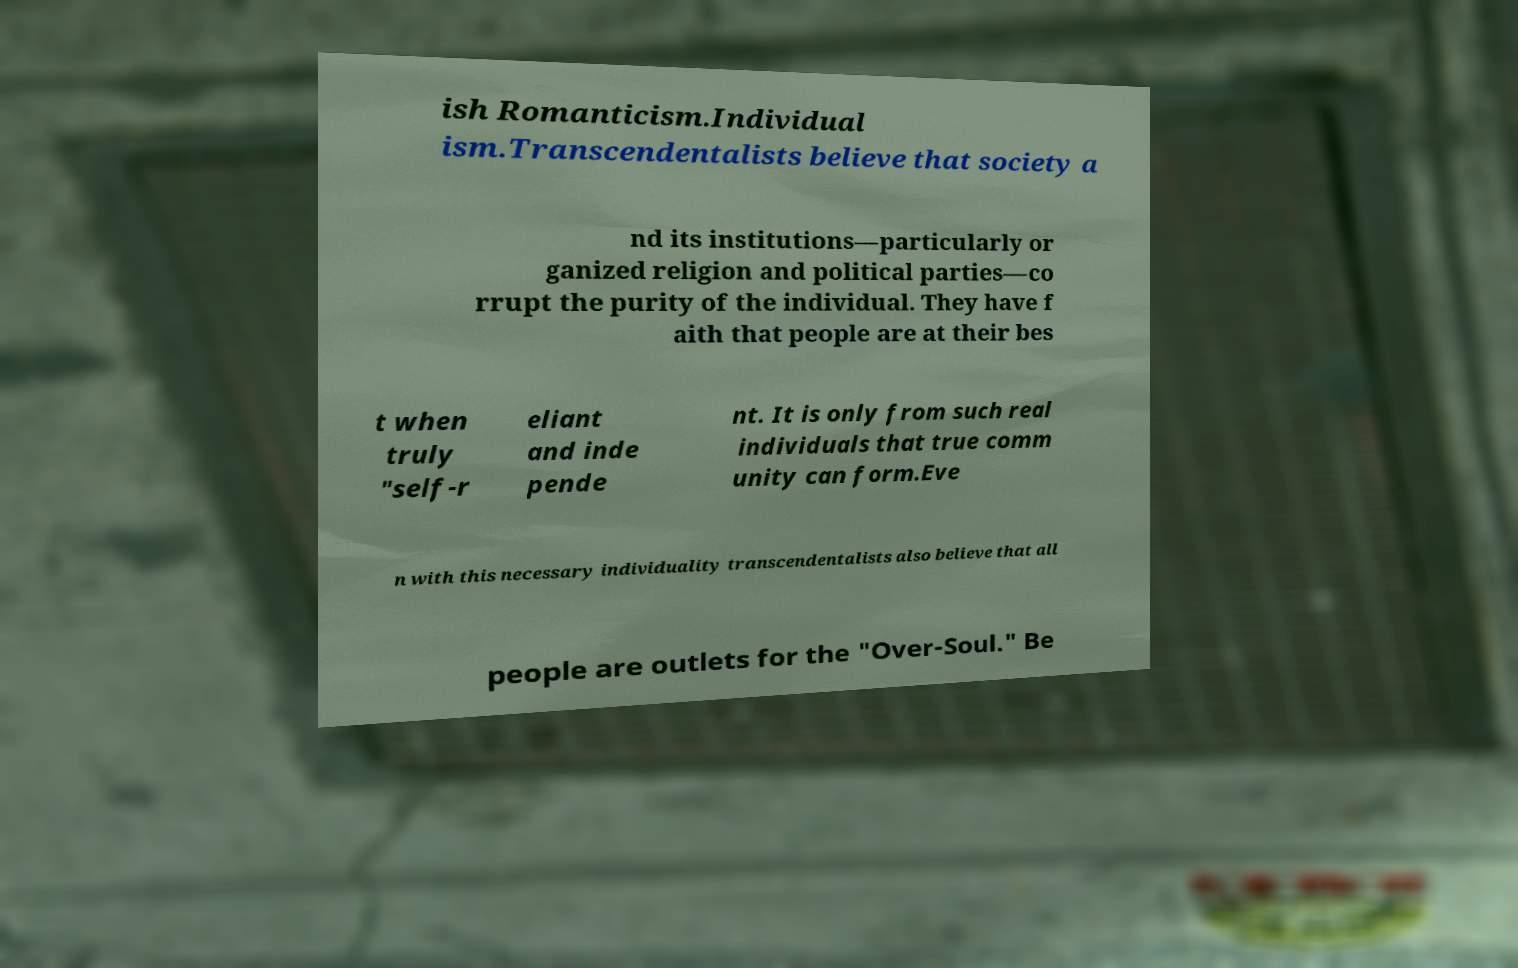Can you read and provide the text displayed in the image?This photo seems to have some interesting text. Can you extract and type it out for me? ish Romanticism.Individual ism.Transcendentalists believe that society a nd its institutions—particularly or ganized religion and political parties—co rrupt the purity of the individual. They have f aith that people are at their bes t when truly "self-r eliant and inde pende nt. It is only from such real individuals that true comm unity can form.Eve n with this necessary individuality transcendentalists also believe that all people are outlets for the "Over-Soul." Be 